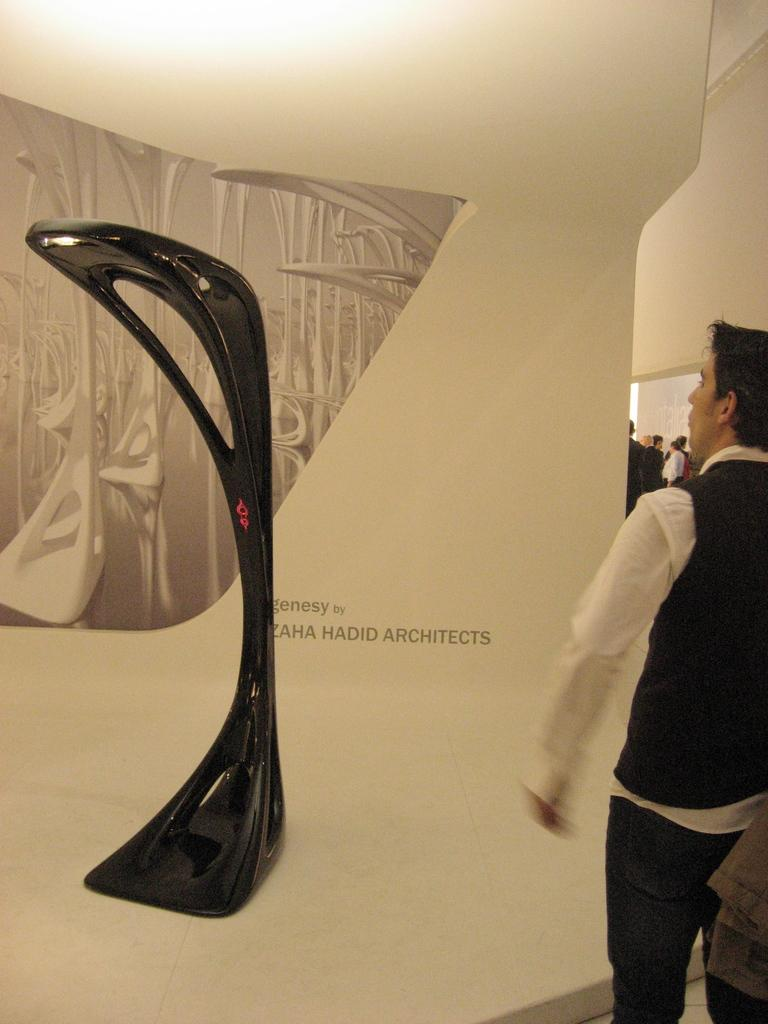What type of lamp is on the floor in the image? There is a genesy lamp on the floor in the image. What can be seen in the background of the image? There is a banner in the background of the image. Where are the people located in the image? The group of people is standing on the right side of the image. What type of crime is being committed in the image? There is no crime being committed in the image; it only features a genesy lamp, a banner, and a group of people. Can you see any rubble or debris in the image? There is no rubble or debris present in the image. 